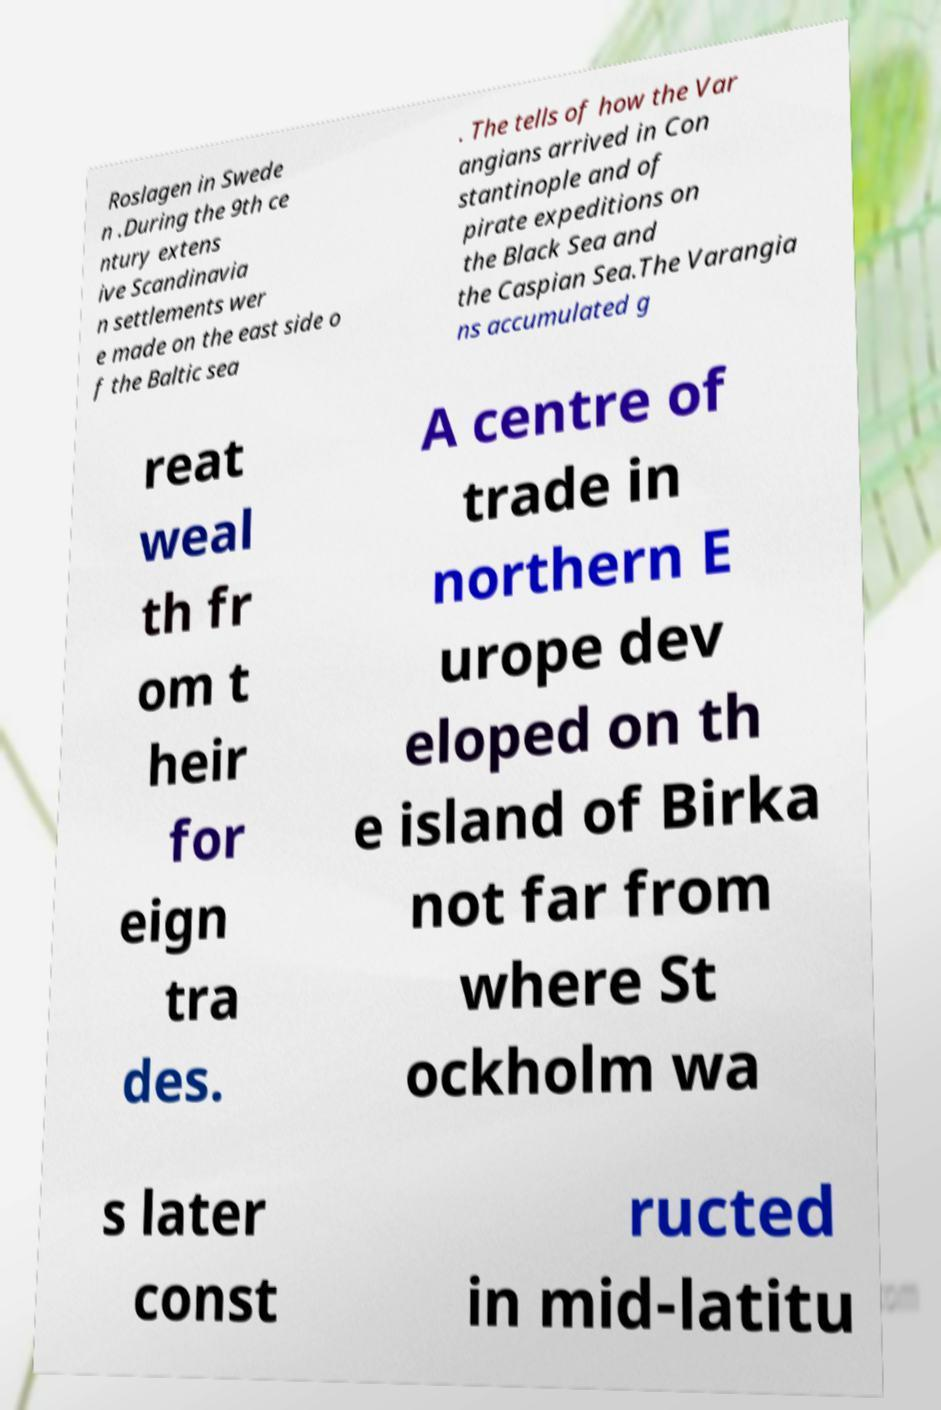For documentation purposes, I need the text within this image transcribed. Could you provide that? Roslagen in Swede n .During the 9th ce ntury extens ive Scandinavia n settlements wer e made on the east side o f the Baltic sea . The tells of how the Var angians arrived in Con stantinople and of pirate expeditions on the Black Sea and the Caspian Sea.The Varangia ns accumulated g reat weal th fr om t heir for eign tra des. A centre of trade in northern E urope dev eloped on th e island of Birka not far from where St ockholm wa s later const ructed in mid-latitu 